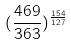<formula> <loc_0><loc_0><loc_500><loc_500>( \frac { 4 6 9 } { 3 6 3 } ) ^ { \frac { 1 5 4 } { 1 2 7 } }</formula> 